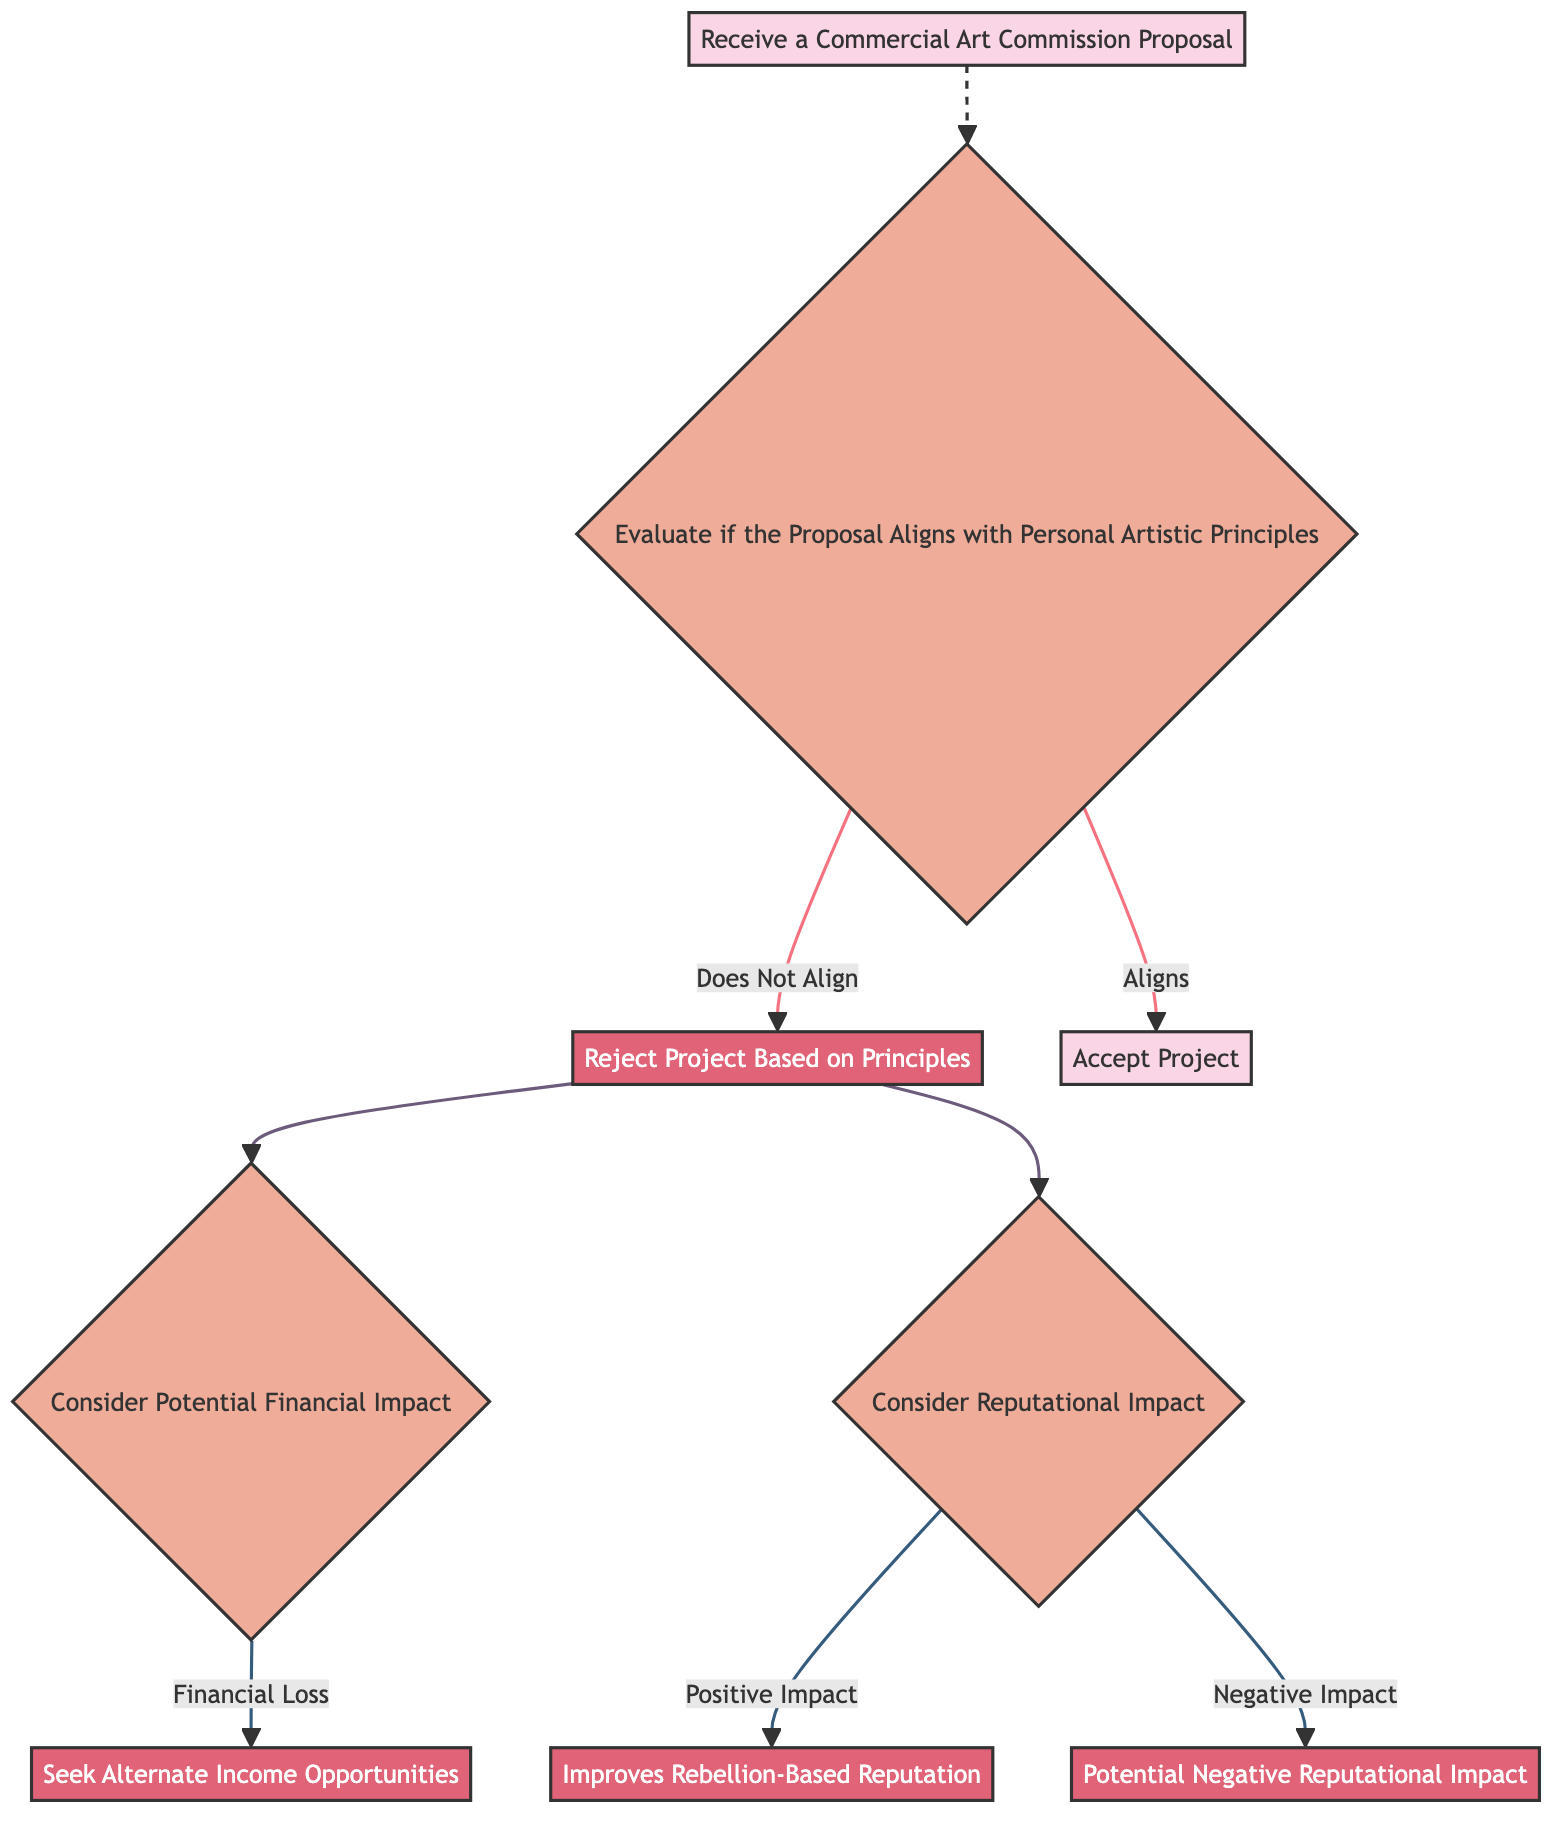What is the first node in the diagram? The first node in the diagram is labeled "Receive a Commercial Art Commission Proposal."
Answer: Receive a Commercial Art Commission Proposal How many connections are there in total? There are eight connections in total, leading from one node to another throughout the diagram.
Answer: Eight What happens if the proposal aligns with personal artistic principles? If the proposal aligns, the next step in the flow is to accept the project, moving to the "Accept Project" node.
Answer: Accept Project What is the outcome of rejecting the project based on principles? The outcome of rejecting the project leads to two considerations: financial impact and reputational impact, branching into further steps from the "Reject Project Based on Principles" node.
Answer: Consider Potential Financial Impact and Consider Reputational Impact If the financial impact indicates financial loss, what is the next action suggested? If there is a financial loss, the diagram suggests seeking alternate income opportunities as the next action to take.
Answer: Seek Alternate Income Opportunities What are the two possible reputational impacts considered after rejecting the project? After rejecting the project, the two possible reputational impacts are a positive impact (improves rebellion-based reputation) and a negative impact (potential negative reputational impact).
Answer: Improves Rebellion-Based Reputation and Potential Negative Reputational Impact What is the final outcome if the reputational impact is positive? If the reputational impact is positive, the final outcome is that it improves the rebellion-based reputation of the artist.
Answer: Improves Rebellion-Based Reputation What does the decision node evaluate in the diagram? The decision node evaluates whether the commercial art commission proposal aligns with the personal artistic principles of the artist.
Answer: Evaluate if the Proposal Aligns with Personal Artistic Principles 